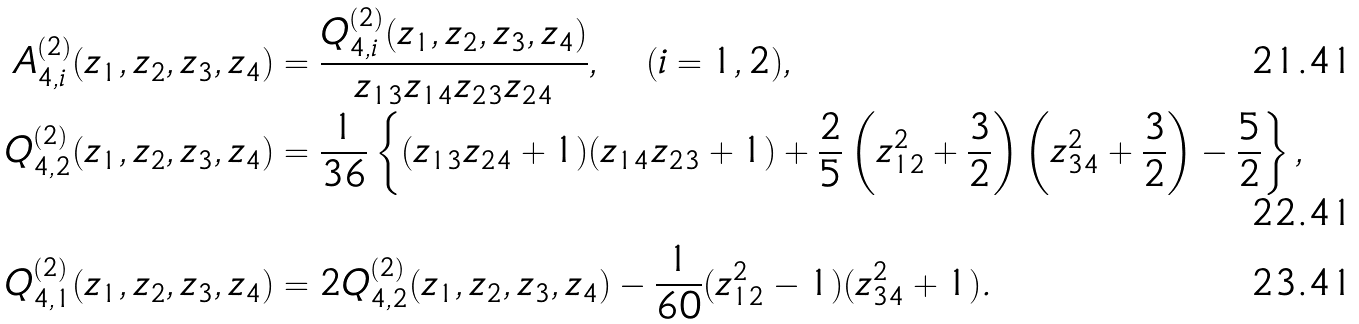<formula> <loc_0><loc_0><loc_500><loc_500>A _ { 4 , i } ^ { ( 2 ) } ( z _ { 1 } , z _ { 2 } , z _ { 3 } , z _ { 4 } ) & = \frac { Q _ { 4 , i } ^ { ( 2 ) } ( z _ { 1 } , z _ { 2 } , z _ { 3 } , z _ { 4 } ) } { z _ { 1 3 } z _ { 1 4 } z _ { 2 3 } z _ { 2 4 } } , \quad ( i = 1 , 2 ) , \\ Q _ { 4 , 2 } ^ { ( 2 ) } ( z _ { 1 } , z _ { 2 } , z _ { 3 } , z _ { 4 } ) & = \frac { 1 } { 3 6 } \left \{ ( z _ { 1 3 } z _ { 2 4 } + 1 ) ( z _ { 1 4 } z _ { 2 3 } + 1 ) + \frac { 2 } { 5 } \left ( z _ { 1 2 } ^ { 2 } + \frac { 3 } { 2 } \right ) \left ( z _ { 3 4 } ^ { 2 } + \frac { 3 } { 2 } \right ) - \frac { 5 } { 2 } \right \} , \\ Q _ { 4 , 1 } ^ { ( 2 ) } ( z _ { 1 } , z _ { 2 } , z _ { 3 } , z _ { 4 } ) & = 2 Q _ { 4 , 2 } ^ { ( 2 ) } ( z _ { 1 } , z _ { 2 } , z _ { 3 } , z _ { 4 } ) - \frac { 1 } { 6 0 } ( z _ { 1 2 } ^ { 2 } - 1 ) ( z _ { 3 4 } ^ { 2 } + 1 ) .</formula> 